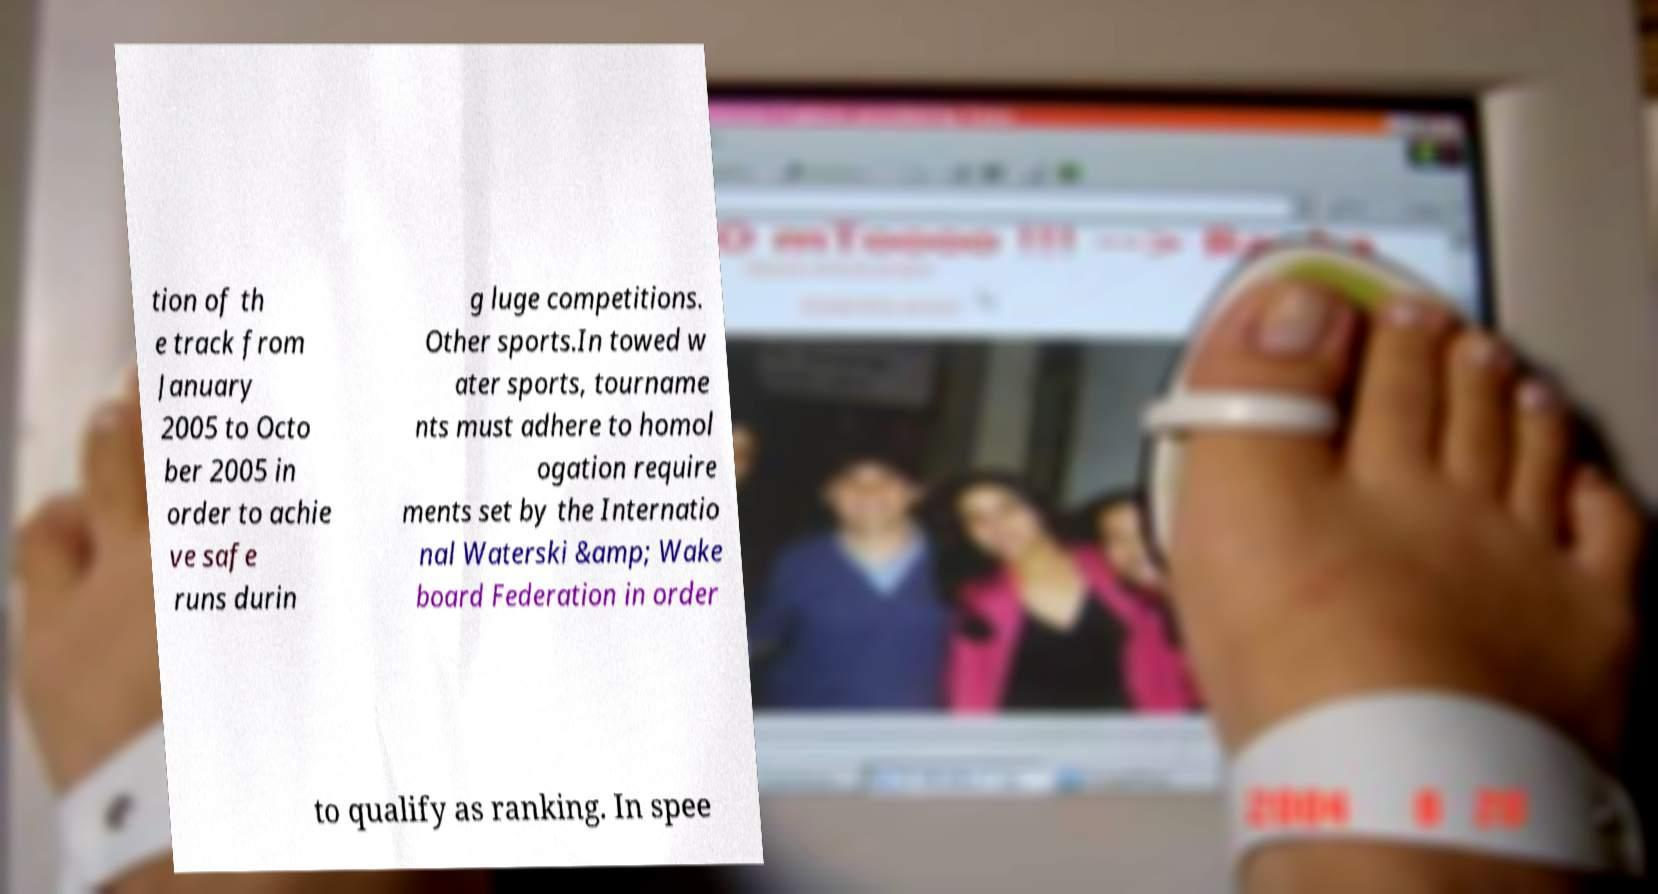Please identify and transcribe the text found in this image. tion of th e track from January 2005 to Octo ber 2005 in order to achie ve safe runs durin g luge competitions. Other sports.In towed w ater sports, tourname nts must adhere to homol ogation require ments set by the Internatio nal Waterski &amp; Wake board Federation in order to qualify as ranking. In spee 